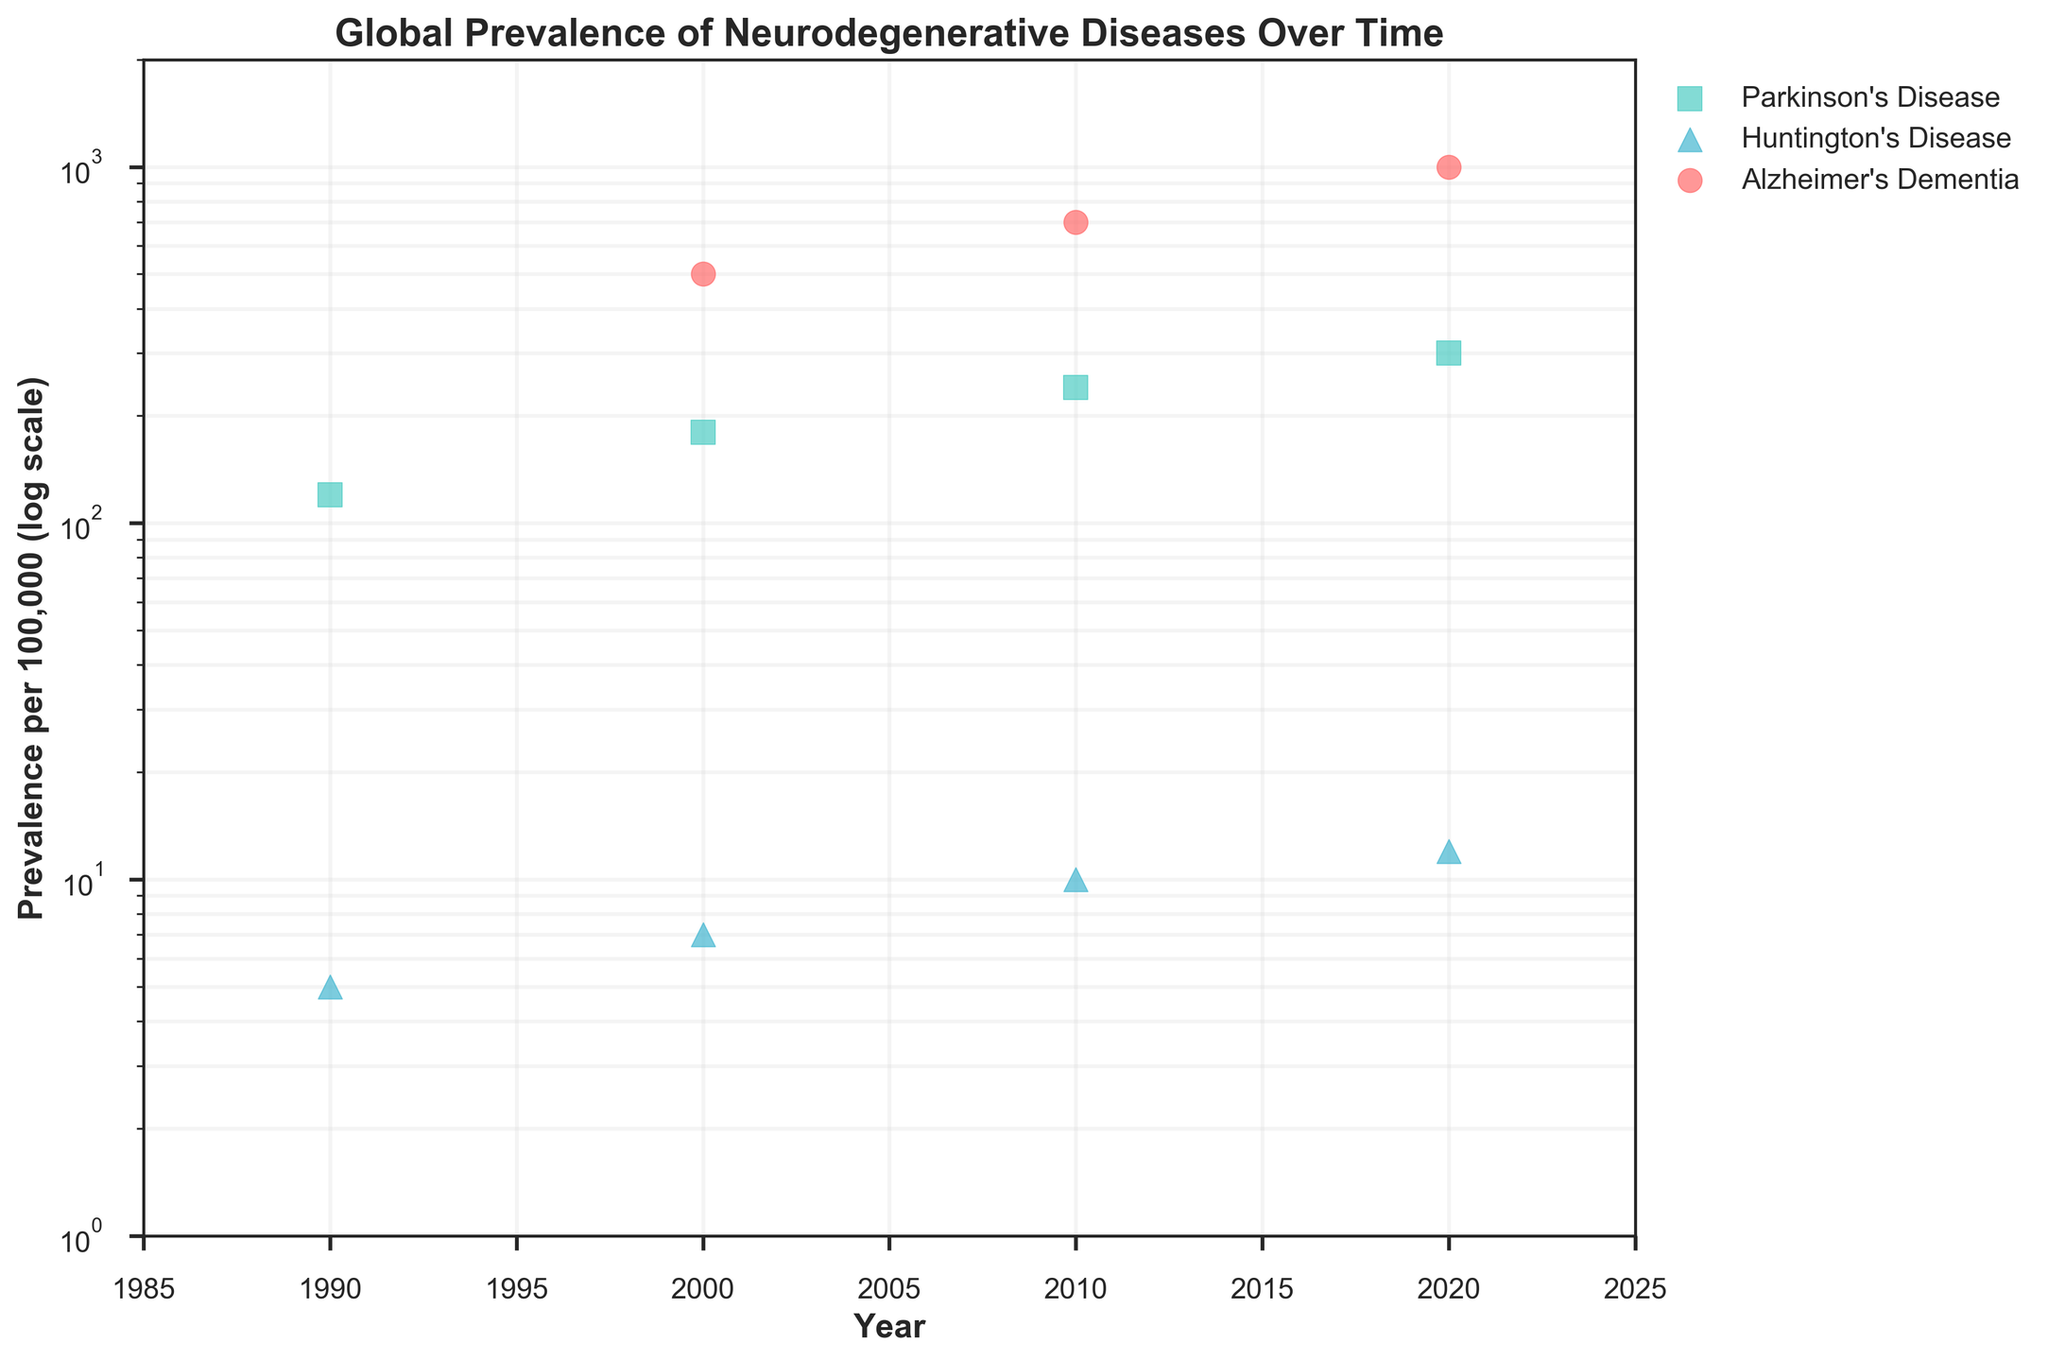What is the title of the scatter plot? The title of the scatter plot is given at the top of the figure. It describes what the plot is about. In this case, it is "Global Prevalence of Neurodegenerative Diseases Over Time."
Answer: Global Prevalence of Neurodegenerative Diseases Over Time Which disease has the highest prevalence per 100,000 in 2020? Look at the data points for the year 2020 and compare the prevalence per 100,000 for each of the diseases. Alzheimer's Dementia shows the highest prevalence around 1000 per 100,000.
Answer: Alzheimer's Dementia What is the general trend of Parkinson's Disease prevalence from 1990 to 2020? Observe the data points for Parkinson's Disease over the years. The prevalence increases from 120 in 1990 to 300 in 2020. This indicates a rising trend.
Answer: Increasing By how much did the prevalence of Huntington's Disease increase from 1990 to 2020? Compare the prevalence values for Huntington's Disease in 1990 and 2020. Subtract the 1990 value (5) from the 2020 value (12) to find the increase.
Answer: 7 How does the prevalence of Alzheimer's Dementia in 2000 compare to 2010? Locate the data points for Alzheimer's Dementia in 2000 and 2010 and compare their heights. In 2000, the prevalence is 500 per 100,000, while in 2010 it increases to 700 per 100,000.
Answer: It increased Which disease shows the least variability in prevalence over time? Look at the data spread for each disease throughout the years. Huntington's Disease shows the least variability, remaining relatively low and stable compared to Alzheimer's and Parkinson's.
Answer: Huntington's Disease How does the prevalence of neurodegenerative diseases change over time in general? Observe the plotted points overall for all diseases. The prevalence of all three diseases generally increases over time, indicating a rising trend in neurodegenerative diseases globally.
Answer: Increasing What is the log scale used for in the Y-axis? A log scale is used in the Y-axis to represent a wide range of data consistently. This helps to visualize data that spans several orders of magnitude without compressing smaller values. It shows exponential growth clearly.
Answer: To represent a wide range of data consistently and show exponential growth 